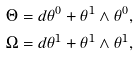<formula> <loc_0><loc_0><loc_500><loc_500>\Theta & = d \theta ^ { 0 } + \theta ^ { 1 } \wedge \theta ^ { 0 } , \\ \Omega & = d \theta ^ { 1 } + \theta ^ { 1 } \wedge \theta ^ { 1 } ,</formula> 